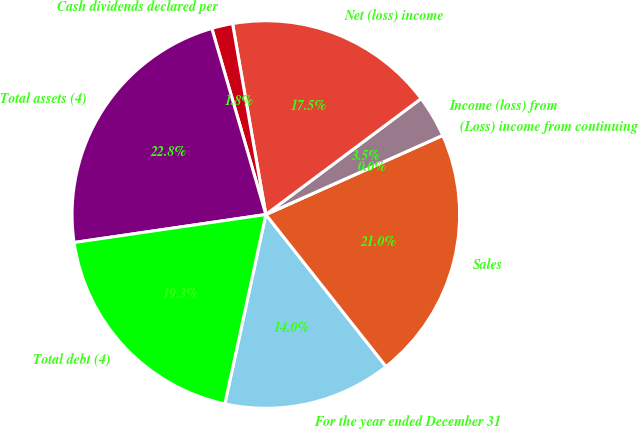Convert chart to OTSL. <chart><loc_0><loc_0><loc_500><loc_500><pie_chart><fcel>For the year ended December 31<fcel>Sales<fcel>(Loss) income from continuing<fcel>Income (loss) from<fcel>Net (loss) income<fcel>Cash dividends declared per<fcel>Total assets (4)<fcel>Total debt (4)<nl><fcel>14.04%<fcel>21.05%<fcel>0.0%<fcel>3.51%<fcel>17.54%<fcel>1.75%<fcel>22.81%<fcel>19.3%<nl></chart> 